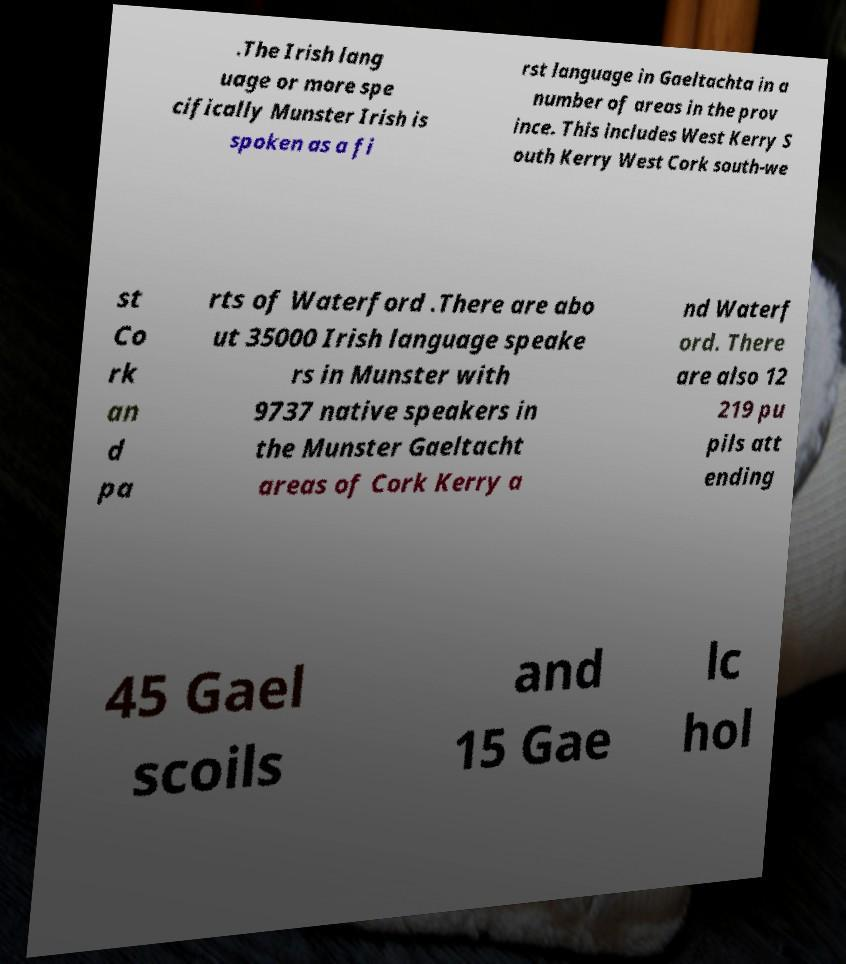I need the written content from this picture converted into text. Can you do that? .The Irish lang uage or more spe cifically Munster Irish is spoken as a fi rst language in Gaeltachta in a number of areas in the prov ince. This includes West Kerry S outh Kerry West Cork south-we st Co rk an d pa rts of Waterford .There are abo ut 35000 Irish language speake rs in Munster with 9737 native speakers in the Munster Gaeltacht areas of Cork Kerry a nd Waterf ord. There are also 12 219 pu pils att ending 45 Gael scoils and 15 Gae lc hol 